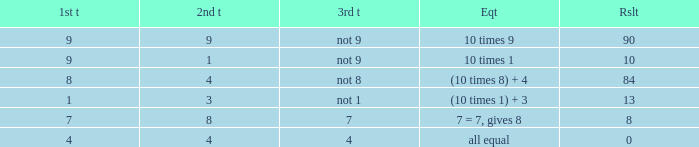What is the equation where the 3rd throw is 7? 7 = 7, gives 8. 